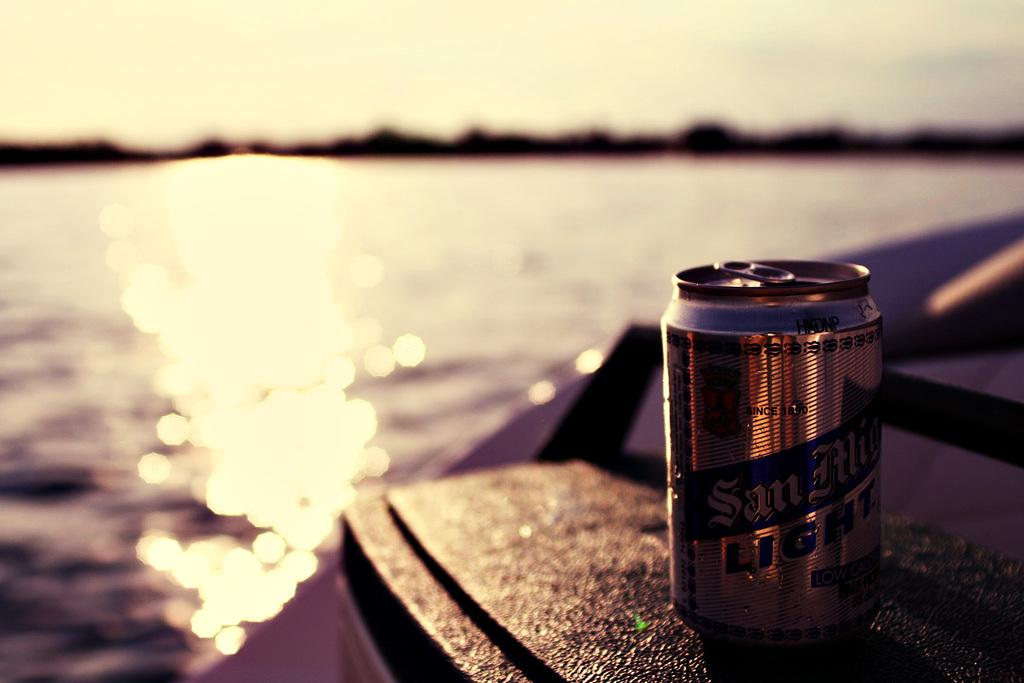Provide a one-sentence caption for the provided image. A lake at sunset with a silver beer can reading San Alig... Light. 